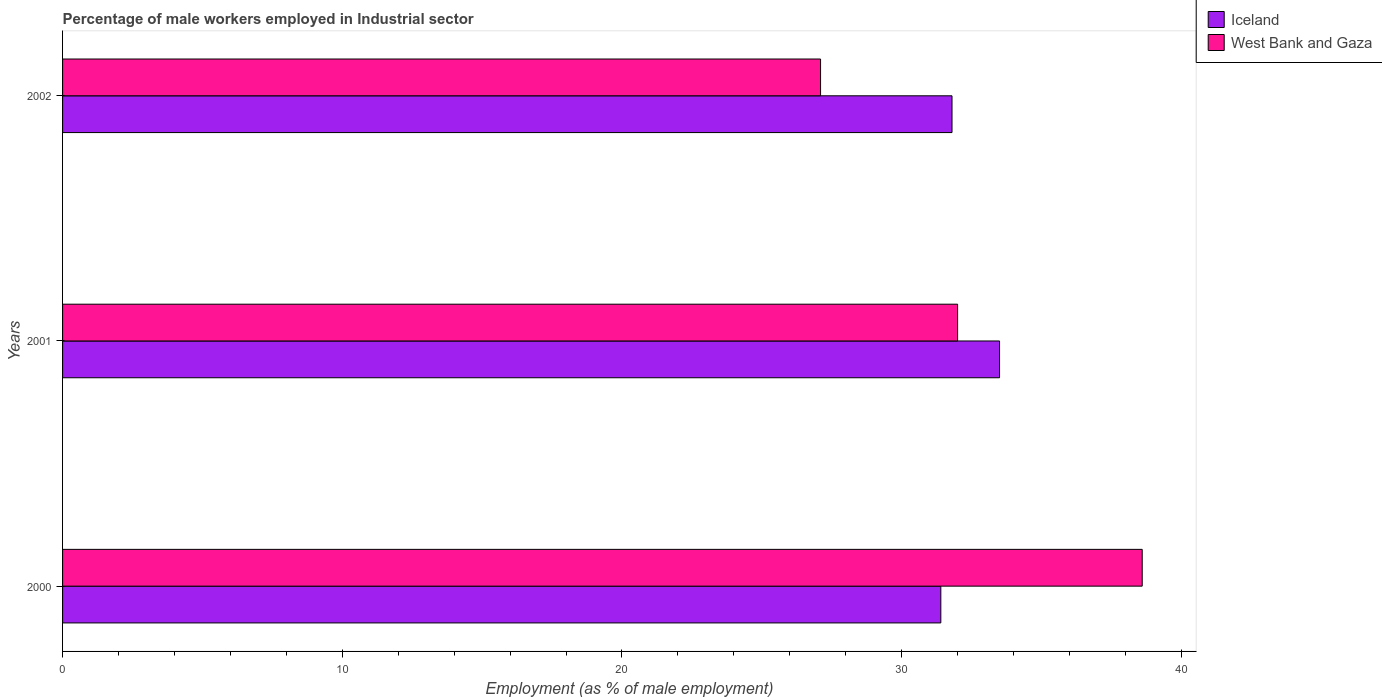How many groups of bars are there?
Ensure brevity in your answer.  3. Are the number of bars per tick equal to the number of legend labels?
Offer a terse response. Yes. Are the number of bars on each tick of the Y-axis equal?
Provide a short and direct response. Yes. What is the percentage of male workers employed in Industrial sector in Iceland in 2000?
Your response must be concise. 31.4. Across all years, what is the maximum percentage of male workers employed in Industrial sector in West Bank and Gaza?
Your response must be concise. 38.6. Across all years, what is the minimum percentage of male workers employed in Industrial sector in Iceland?
Provide a short and direct response. 31.4. In which year was the percentage of male workers employed in Industrial sector in Iceland maximum?
Provide a succinct answer. 2001. In which year was the percentage of male workers employed in Industrial sector in Iceland minimum?
Your answer should be very brief. 2000. What is the total percentage of male workers employed in Industrial sector in Iceland in the graph?
Provide a succinct answer. 96.7. What is the difference between the percentage of male workers employed in Industrial sector in Iceland in 2000 and that in 2002?
Give a very brief answer. -0.4. What is the difference between the percentage of male workers employed in Industrial sector in Iceland in 2001 and the percentage of male workers employed in Industrial sector in West Bank and Gaza in 2002?
Offer a very short reply. 6.4. What is the average percentage of male workers employed in Industrial sector in West Bank and Gaza per year?
Keep it short and to the point. 32.57. In the year 2001, what is the difference between the percentage of male workers employed in Industrial sector in West Bank and Gaza and percentage of male workers employed in Industrial sector in Iceland?
Offer a very short reply. -1.5. What is the ratio of the percentage of male workers employed in Industrial sector in Iceland in 2000 to that in 2002?
Offer a very short reply. 0.99. Is the percentage of male workers employed in Industrial sector in West Bank and Gaza in 2001 less than that in 2002?
Offer a very short reply. No. Is the difference between the percentage of male workers employed in Industrial sector in West Bank and Gaza in 2000 and 2002 greater than the difference between the percentage of male workers employed in Industrial sector in Iceland in 2000 and 2002?
Ensure brevity in your answer.  Yes. What is the difference between the highest and the second highest percentage of male workers employed in Industrial sector in Iceland?
Make the answer very short. 1.7. What is the difference between the highest and the lowest percentage of male workers employed in Industrial sector in West Bank and Gaza?
Your answer should be very brief. 11.5. In how many years, is the percentage of male workers employed in Industrial sector in Iceland greater than the average percentage of male workers employed in Industrial sector in Iceland taken over all years?
Keep it short and to the point. 1. Is the sum of the percentage of male workers employed in Industrial sector in West Bank and Gaza in 2000 and 2001 greater than the maximum percentage of male workers employed in Industrial sector in Iceland across all years?
Your answer should be compact. Yes. What does the 2nd bar from the top in 2002 represents?
Your answer should be very brief. Iceland. Are all the bars in the graph horizontal?
Your answer should be compact. Yes. How many years are there in the graph?
Your response must be concise. 3. Does the graph contain grids?
Make the answer very short. No. Where does the legend appear in the graph?
Your answer should be compact. Top right. What is the title of the graph?
Provide a succinct answer. Percentage of male workers employed in Industrial sector. Does "Libya" appear as one of the legend labels in the graph?
Offer a very short reply. No. What is the label or title of the X-axis?
Keep it short and to the point. Employment (as % of male employment). What is the Employment (as % of male employment) in Iceland in 2000?
Make the answer very short. 31.4. What is the Employment (as % of male employment) of West Bank and Gaza in 2000?
Offer a very short reply. 38.6. What is the Employment (as % of male employment) of Iceland in 2001?
Your answer should be compact. 33.5. What is the Employment (as % of male employment) of Iceland in 2002?
Provide a short and direct response. 31.8. What is the Employment (as % of male employment) in West Bank and Gaza in 2002?
Provide a short and direct response. 27.1. Across all years, what is the maximum Employment (as % of male employment) of Iceland?
Provide a succinct answer. 33.5. Across all years, what is the maximum Employment (as % of male employment) in West Bank and Gaza?
Make the answer very short. 38.6. Across all years, what is the minimum Employment (as % of male employment) in Iceland?
Your answer should be very brief. 31.4. Across all years, what is the minimum Employment (as % of male employment) of West Bank and Gaza?
Provide a succinct answer. 27.1. What is the total Employment (as % of male employment) in Iceland in the graph?
Provide a succinct answer. 96.7. What is the total Employment (as % of male employment) of West Bank and Gaza in the graph?
Provide a short and direct response. 97.7. What is the difference between the Employment (as % of male employment) of Iceland in 2000 and that in 2001?
Offer a terse response. -2.1. What is the difference between the Employment (as % of male employment) in West Bank and Gaza in 2000 and that in 2001?
Offer a very short reply. 6.6. What is the difference between the Employment (as % of male employment) in Iceland in 2000 and that in 2002?
Give a very brief answer. -0.4. What is the difference between the Employment (as % of male employment) of West Bank and Gaza in 2000 and that in 2002?
Provide a short and direct response. 11.5. What is the difference between the Employment (as % of male employment) of Iceland in 2001 and that in 2002?
Ensure brevity in your answer.  1.7. What is the difference between the Employment (as % of male employment) in Iceland in 2000 and the Employment (as % of male employment) in West Bank and Gaza in 2001?
Your answer should be very brief. -0.6. What is the difference between the Employment (as % of male employment) in Iceland in 2000 and the Employment (as % of male employment) in West Bank and Gaza in 2002?
Ensure brevity in your answer.  4.3. What is the difference between the Employment (as % of male employment) of Iceland in 2001 and the Employment (as % of male employment) of West Bank and Gaza in 2002?
Make the answer very short. 6.4. What is the average Employment (as % of male employment) in Iceland per year?
Provide a succinct answer. 32.23. What is the average Employment (as % of male employment) in West Bank and Gaza per year?
Keep it short and to the point. 32.57. In the year 2001, what is the difference between the Employment (as % of male employment) in Iceland and Employment (as % of male employment) in West Bank and Gaza?
Your answer should be very brief. 1.5. In the year 2002, what is the difference between the Employment (as % of male employment) of Iceland and Employment (as % of male employment) of West Bank and Gaza?
Ensure brevity in your answer.  4.7. What is the ratio of the Employment (as % of male employment) of Iceland in 2000 to that in 2001?
Keep it short and to the point. 0.94. What is the ratio of the Employment (as % of male employment) in West Bank and Gaza in 2000 to that in 2001?
Provide a succinct answer. 1.21. What is the ratio of the Employment (as % of male employment) in Iceland in 2000 to that in 2002?
Ensure brevity in your answer.  0.99. What is the ratio of the Employment (as % of male employment) of West Bank and Gaza in 2000 to that in 2002?
Give a very brief answer. 1.42. What is the ratio of the Employment (as % of male employment) in Iceland in 2001 to that in 2002?
Offer a terse response. 1.05. What is the ratio of the Employment (as % of male employment) in West Bank and Gaza in 2001 to that in 2002?
Ensure brevity in your answer.  1.18. What is the difference between the highest and the second highest Employment (as % of male employment) of Iceland?
Offer a very short reply. 1.7. What is the difference between the highest and the second highest Employment (as % of male employment) in West Bank and Gaza?
Ensure brevity in your answer.  6.6. What is the difference between the highest and the lowest Employment (as % of male employment) in West Bank and Gaza?
Make the answer very short. 11.5. 